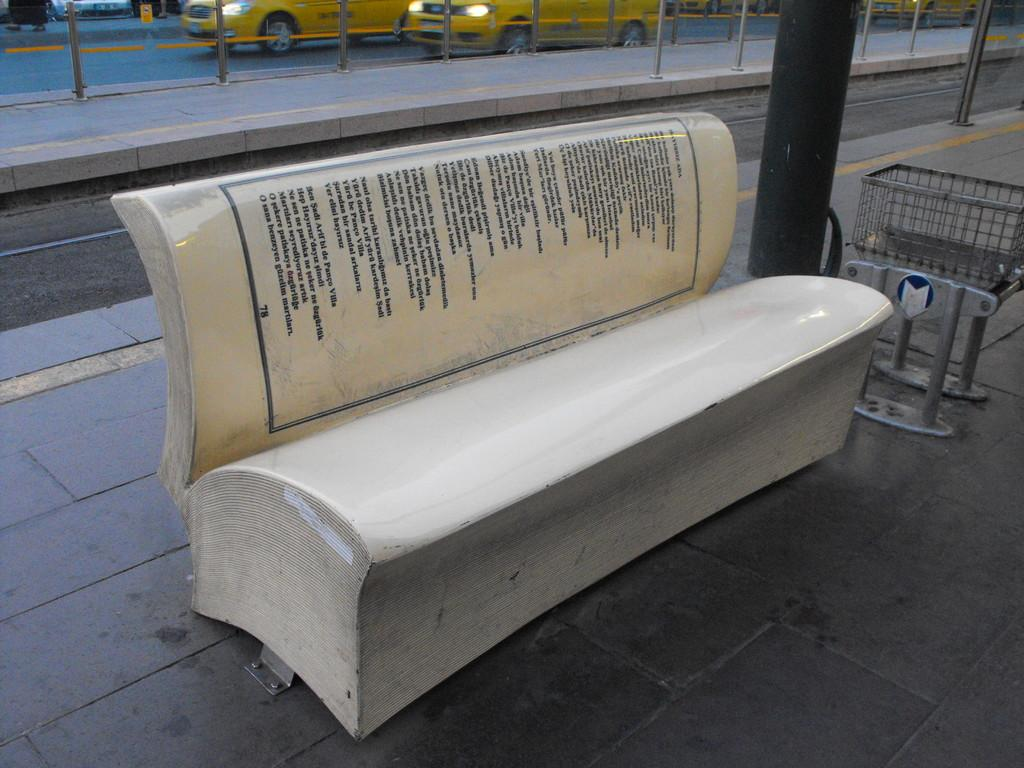What can be seen in the background of the image? In the background of the image, there are vehicles, poles, and a road. Can you describe the bench in the image? There is a bench in the image, and it has some information on it. What type of objects are present in the image? There are objects in the image, but their specific nature is not mentioned in the facts. What is the pillar in the image used for? The facts do not specify the purpose of the pillar in the image. What type of metal is the rock made of in the image? There is no rock or metal present in the image. What authority figure can be seen in the image? The facts do not mention any authority figures in the image. 